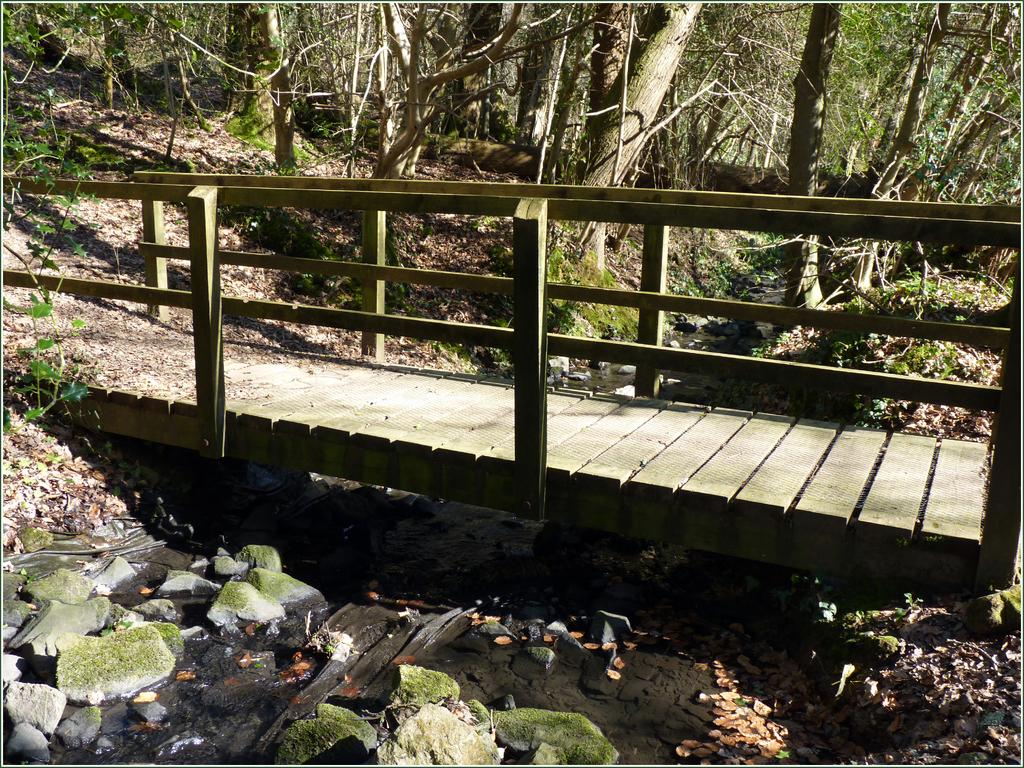What structure is the main subject of the image? There is a bridge in the image. What type of material can be seen in the image? There are stones visible in the image. What can be seen in the background of the image? There are trees in the background of the image. What type of beast is hiding behind the trees in the image? There is no beast present in the image; it only features a bridge, stones, and trees. 